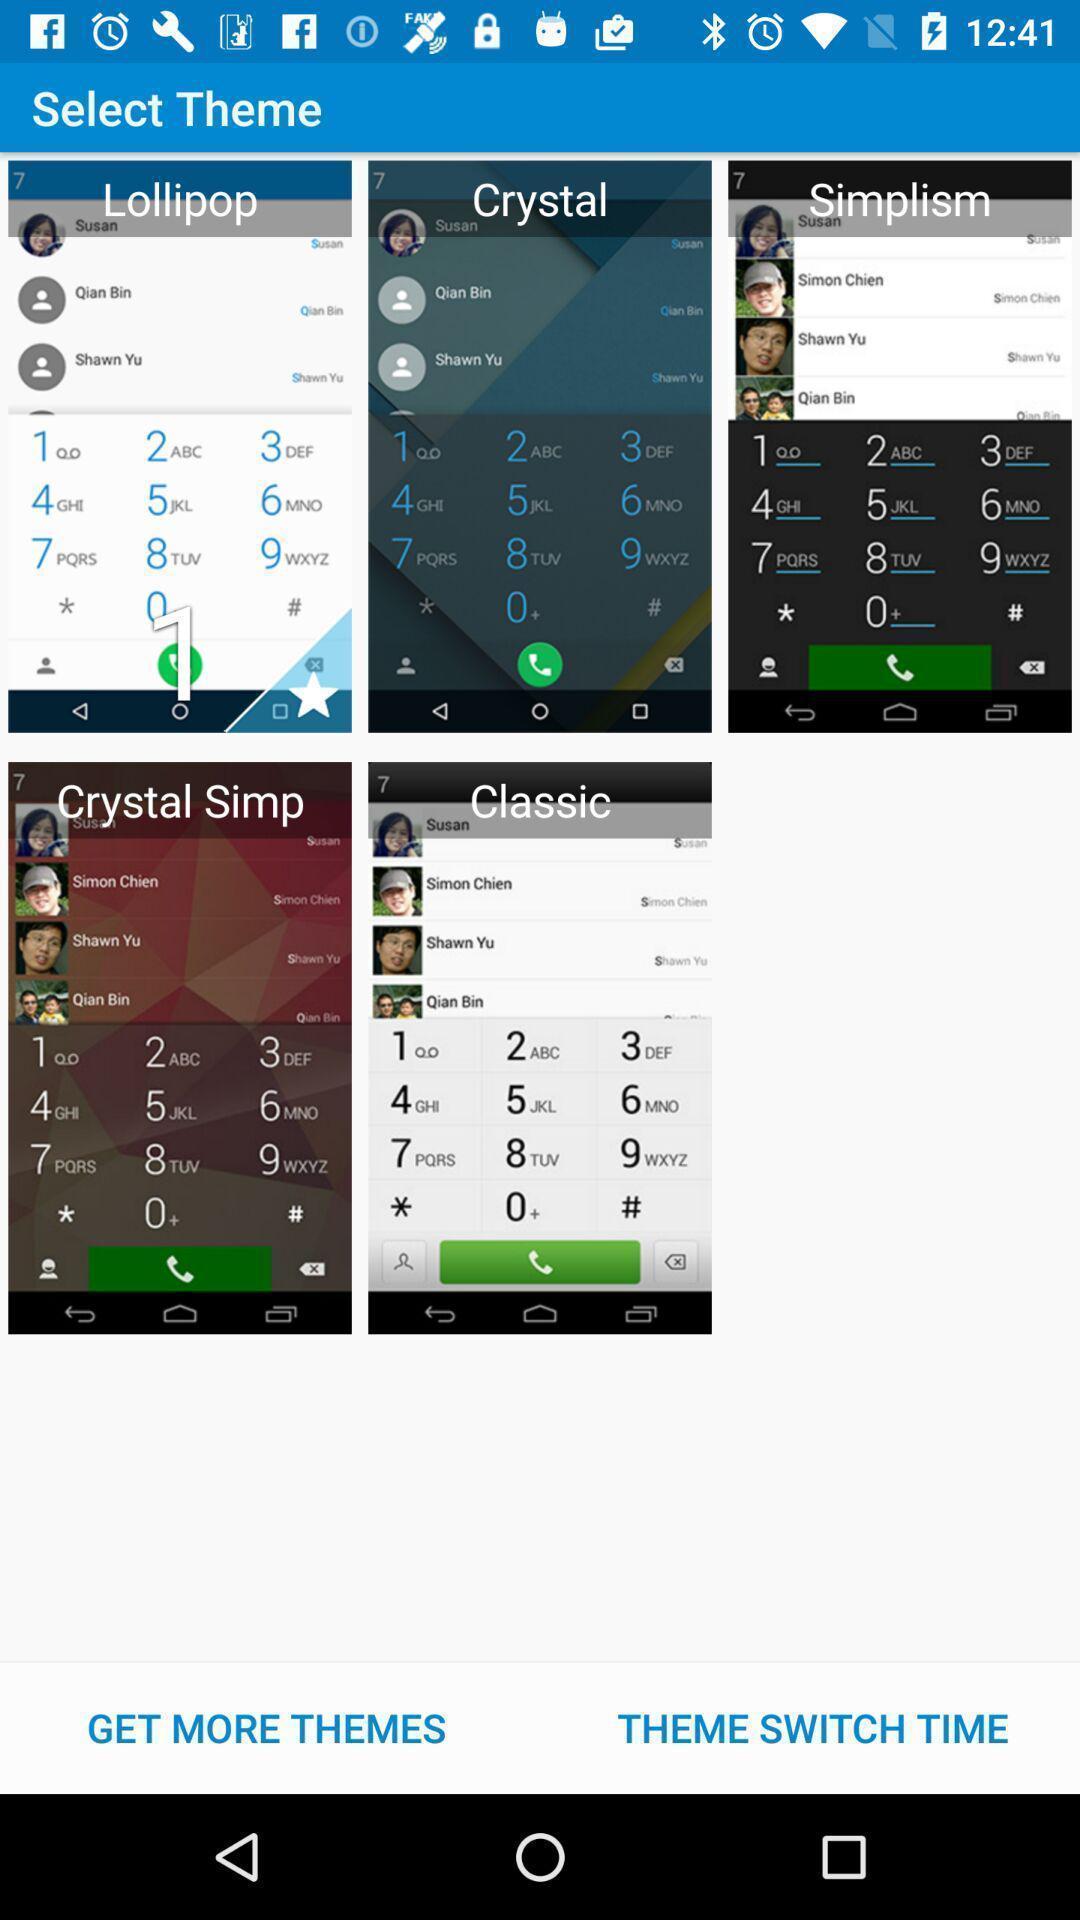Describe this image in words. Page showing the multiple themes available. 